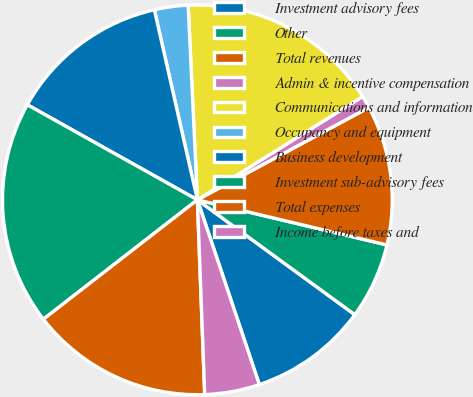Convert chart to OTSL. <chart><loc_0><loc_0><loc_500><loc_500><pie_chart><fcel>Investment advisory fees<fcel>Other<fcel>Total revenues<fcel>Admin & incentive compensation<fcel>Communications and information<fcel>Occupancy and equipment<fcel>Business development<fcel>Investment sub-advisory fees<fcel>Total expenses<fcel>Income before taxes and<nl><fcel>9.82%<fcel>6.31%<fcel>11.58%<fcel>1.03%<fcel>16.86%<fcel>2.79%<fcel>13.34%<fcel>18.61%<fcel>15.1%<fcel>4.55%<nl></chart> 